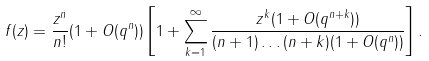<formula> <loc_0><loc_0><loc_500><loc_500>f ( z ) = \frac { z ^ { n } } { n ! } ( 1 + O ( q ^ { n } ) ) \left [ 1 + \sum _ { k = 1 } ^ { \infty } \frac { z ^ { k } ( 1 + O ( q ^ { n + k } ) ) } { ( n + 1 ) \dots ( n + k ) ( 1 + O ( q ^ { n } ) ) } \right ] .</formula> 